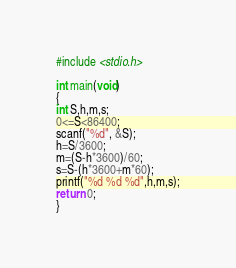Convert code to text. <code><loc_0><loc_0><loc_500><loc_500><_C_>#include <stdio.h>

int main(void)
{
int S,h,m,s;
0<=S<86400;
scanf("%d", &S);
h=S/3600;
m=(S-h*3600)/60;
s=S-(h*3600+m*60);
printf("%d %d %d",h,m,s);
return 0;
}</code> 